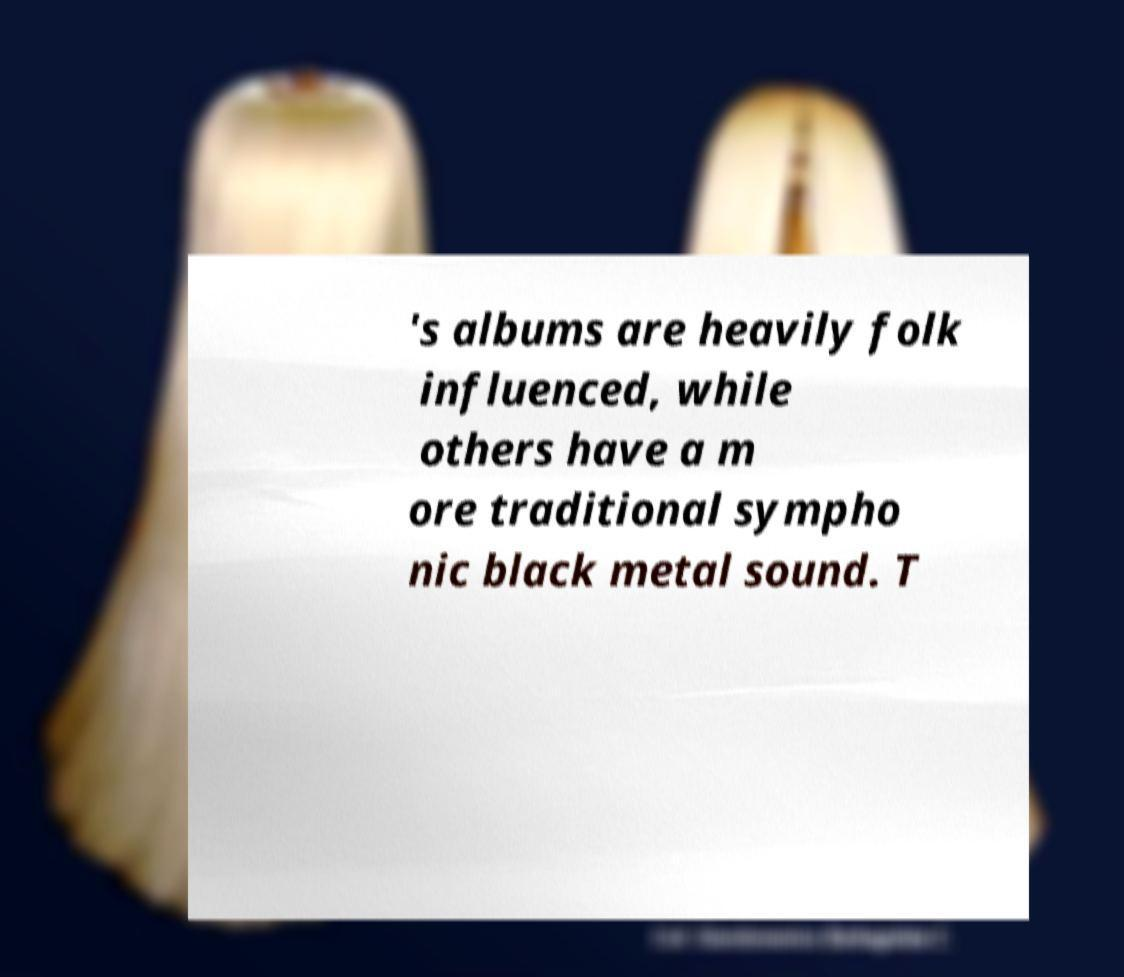For documentation purposes, I need the text within this image transcribed. Could you provide that? 's albums are heavily folk influenced, while others have a m ore traditional sympho nic black metal sound. T 